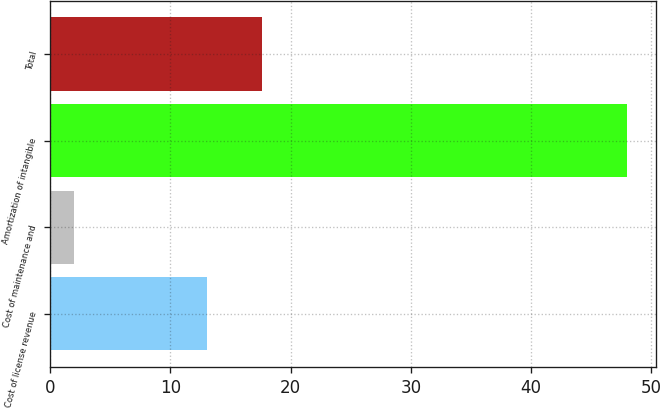Convert chart to OTSL. <chart><loc_0><loc_0><loc_500><loc_500><bar_chart><fcel>Cost of license revenue<fcel>Cost of maintenance and<fcel>Amortization of intangible<fcel>Total<nl><fcel>13<fcel>2<fcel>48<fcel>17.6<nl></chart> 